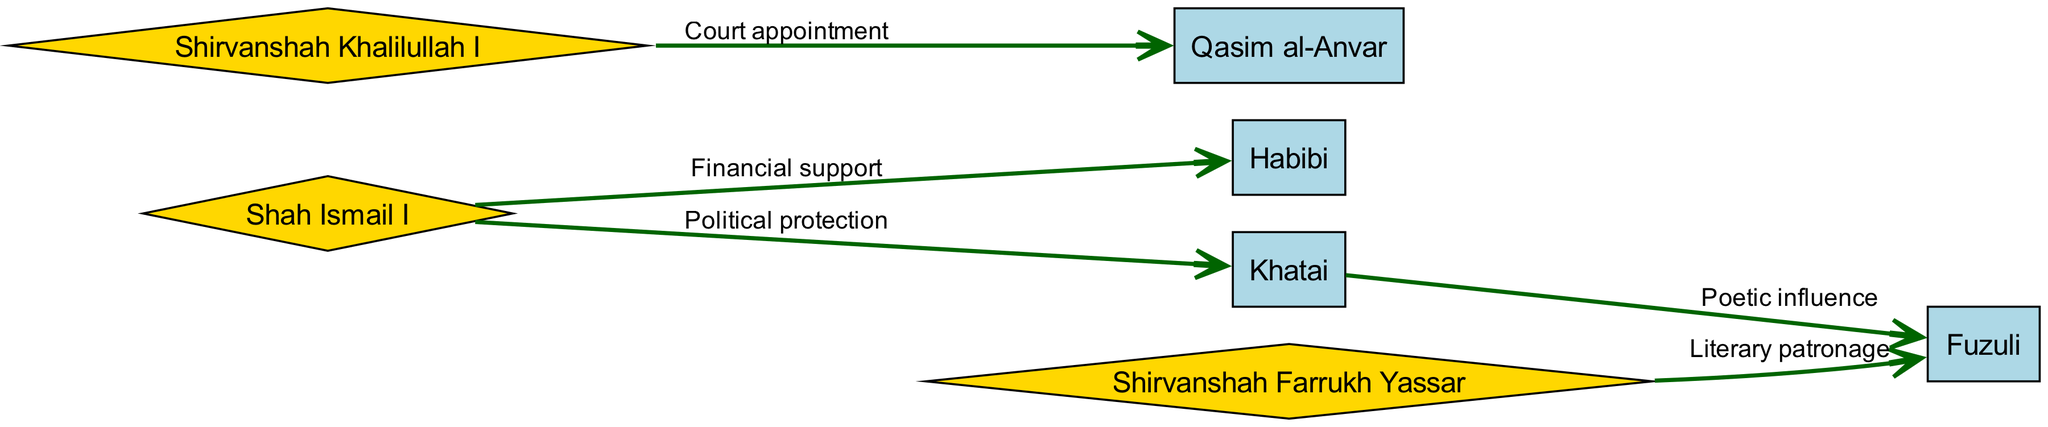What are the total number of nodes in the diagram? The diagram contains a total of 7 nodes representing poets and ruling families. The nodes are Shah Ismail I, Habibi, Qasim al-Anvar, Shirvanshah Khalilullah I, Khatai, Fuzuli, and Shirvanshah Farrukh Yassar.
Answer: 7 Which poet received financial support from Shah Ismail I? The edge from Shah Ismail I to Habibi is labeled "Financial support", indicating that Habibi received financial support from Shah Ismail I.
Answer: Habibi What type of support did Shah Ismail I provide to Khatai? The edge from Shah Ismail I to Khatai is labeled "Political protection", which specifies the type of support provided.
Answer: Political protection Who appointed Qasim al-Anvar to a court position? The edge from Shirvanshah Khalilullah I to Qasim al-Anvar is labeled "Court appointment", indicating that Shirvanshah Khalilullah I was responsible for appointing Qasim al-Anvar to a court role.
Answer: Shirvanshah Khalilullah I Which two entities are connected by a poetic influence relationship? There is an edge from Khatai to Fuzuli labeled "Poetic influence", indicating that these two entities have a relationship characterized by poetic influence.
Answer: Khatai and Fuzuli How many relationships are depicted in the graph? The diagram contains 5 edges representing different types of relationships between the nodes. By counting the connections in the edges list, we can confirm there are 5 relationships.
Answer: 5 What is the nature of the relationship between Shirvanshah Farrukh Yassar and Fuzuli? The connection from Shirvanshah Farrukh Yassar to Fuzuli is labeled "Literary patronage", indicating the specific nature of their relationship.
Answer: Literary patronage Which ruling family has a directed edge to the most poets? By analyzing the edges, Shah Ismail I and Shirvanshah Farrukh Yassar direct their support to one poet each, while Shirvanshah Khalilullah I appoints one poet. All ruling families support one poet or fewer in this graph, thus no ruling family stands out more than the others.
Answer: None What is the source of political protection for Khatai? The edge indicates that Shah Ismail I provides the political protection to Khatai, making him the source of this support.
Answer: Shah Ismail I 